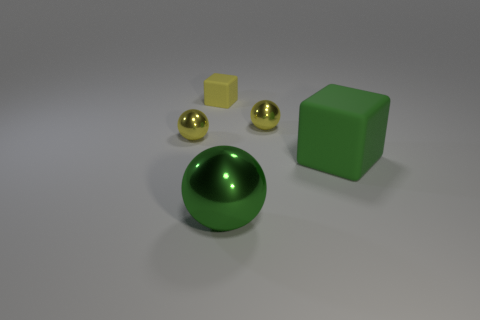Is there a large red cylinder that has the same material as the small yellow cube?
Your answer should be very brief. No. There is a small yellow metal object left of the small yellow cube; is it the same shape as the small yellow thing that is to the right of the yellow rubber thing?
Offer a very short reply. Yes. Are there any small yellow rubber things?
Make the answer very short. Yes. What number of tiny yellow metal objects are the same shape as the large rubber object?
Keep it short and to the point. 0. Is the material of the tiny ball that is to the right of the big green ball the same as the tiny yellow cube?
Your answer should be compact. No. What number of cylinders are large objects or large green matte things?
Provide a short and direct response. 0. There is a metallic thing in front of the small sphere in front of the small shiny sphere right of the big green ball; what is its shape?
Offer a terse response. Sphere. What shape is the metal object that is the same color as the big rubber cube?
Your answer should be compact. Sphere. How many spheres are the same size as the yellow rubber object?
Offer a very short reply. 2. Is there a small yellow shiny sphere in front of the cube that is behind the large green matte cube?
Keep it short and to the point. Yes. 